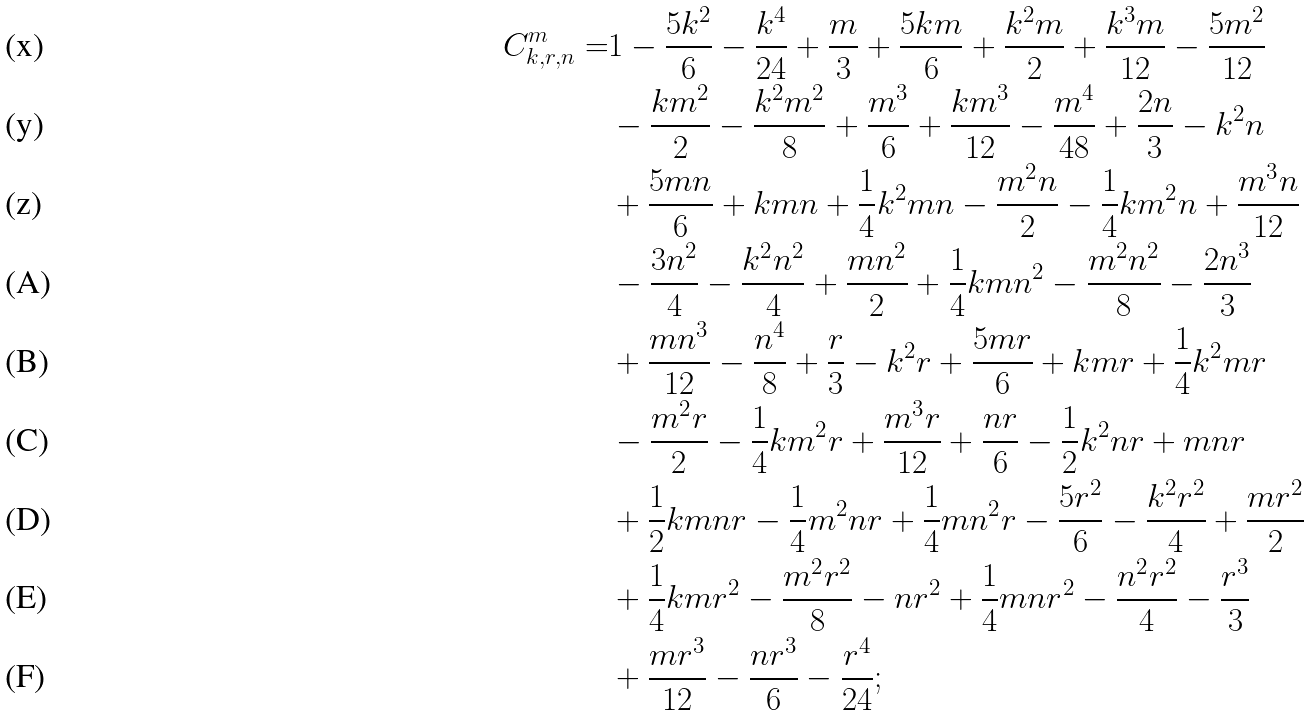<formula> <loc_0><loc_0><loc_500><loc_500>C ^ { m } _ { k , r , n } = & 1 - \frac { 5 k ^ { 2 } } { 6 } - \frac { k ^ { 4 } } { 2 4 } + \frac { m } { 3 } + \frac { 5 k m } { 6 } + \frac { k ^ { 2 } m } { 2 } + \frac { k ^ { 3 } m } { 1 2 } - \frac { 5 m ^ { 2 } } { 1 2 } \quad \ \\ & - \frac { k m ^ { 2 } } { 2 } - \frac { k ^ { 2 } m ^ { 2 } } { 8 } + \frac { m ^ { 3 } } { 6 } + \frac { k m ^ { 3 } } { 1 2 } - \frac { m ^ { 4 } } { 4 8 } + \frac { 2 n } { 3 } - k ^ { 2 } n \\ & + \frac { 5 m n } { 6 } + k m n + \frac { 1 } { 4 } k ^ { 2 } m n - \frac { m ^ { 2 } n } { 2 } - \frac { 1 } { 4 } k m ^ { 2 } n + \frac { m ^ { 3 } n } { 1 2 } \\ & - \frac { 3 n ^ { 2 } } { 4 } - \frac { k ^ { 2 } n ^ { 2 } } { 4 } + \frac { m n ^ { 2 } } { 2 } + \frac { 1 } { 4 } k m n ^ { 2 } - \frac { m ^ { 2 } n ^ { 2 } } { 8 } - \frac { 2 n ^ { 3 } } { 3 } \\ & + \frac { m n ^ { 3 } } { 1 2 } - \frac { n ^ { 4 } } { 8 } + \frac { r } { 3 } - k ^ { 2 } r + \frac { 5 m r } { 6 } + k m r + \frac { 1 } { 4 } k ^ { 2 } m r \\ & - \frac { m ^ { 2 } r } { 2 } - \frac { 1 } { 4 } k m ^ { 2 } r + \frac { m ^ { 3 } r } { 1 2 } + \frac { n r } { 6 } - \frac { 1 } { 2 } k ^ { 2 } n r + m n r \\ & + \frac { 1 } { 2 } k m n r - \frac { 1 } { 4 } m ^ { 2 } n r + \frac { 1 } { 4 } m n ^ { 2 } r - \frac { 5 r ^ { 2 } } { 6 } - \frac { k ^ { 2 } r ^ { 2 } } { 4 } + \frac { m r ^ { 2 } } { 2 } \\ & + \frac { 1 } { 4 } k m r ^ { 2 } - \frac { m ^ { 2 } r ^ { 2 } } { 8 } - n r ^ { 2 } + \frac { 1 } { 4 } m n r ^ { 2 } - \frac { n ^ { 2 } r ^ { 2 } } { 4 } - \frac { r ^ { 3 } } { 3 } \\ & + \frac { m r ^ { 3 } } { 1 2 } - \frac { n r ^ { 3 } } { 6 } - \frac { r ^ { 4 } } { 2 4 } ;</formula> 